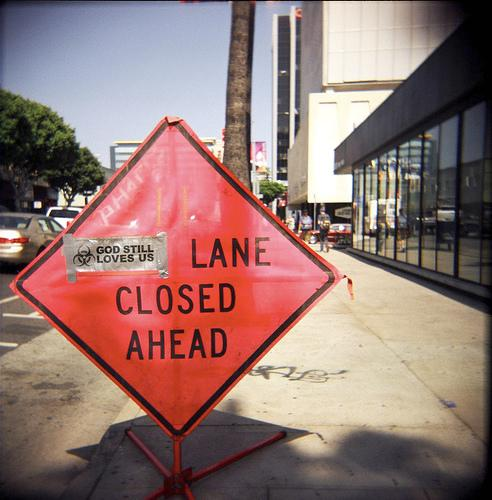How was something added to this sign most recently? sticker 